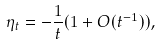Convert formula to latex. <formula><loc_0><loc_0><loc_500><loc_500>\eta _ { t } = - \frac { 1 } { t } ( 1 + O ( t ^ { - 1 } ) ) ,</formula> 